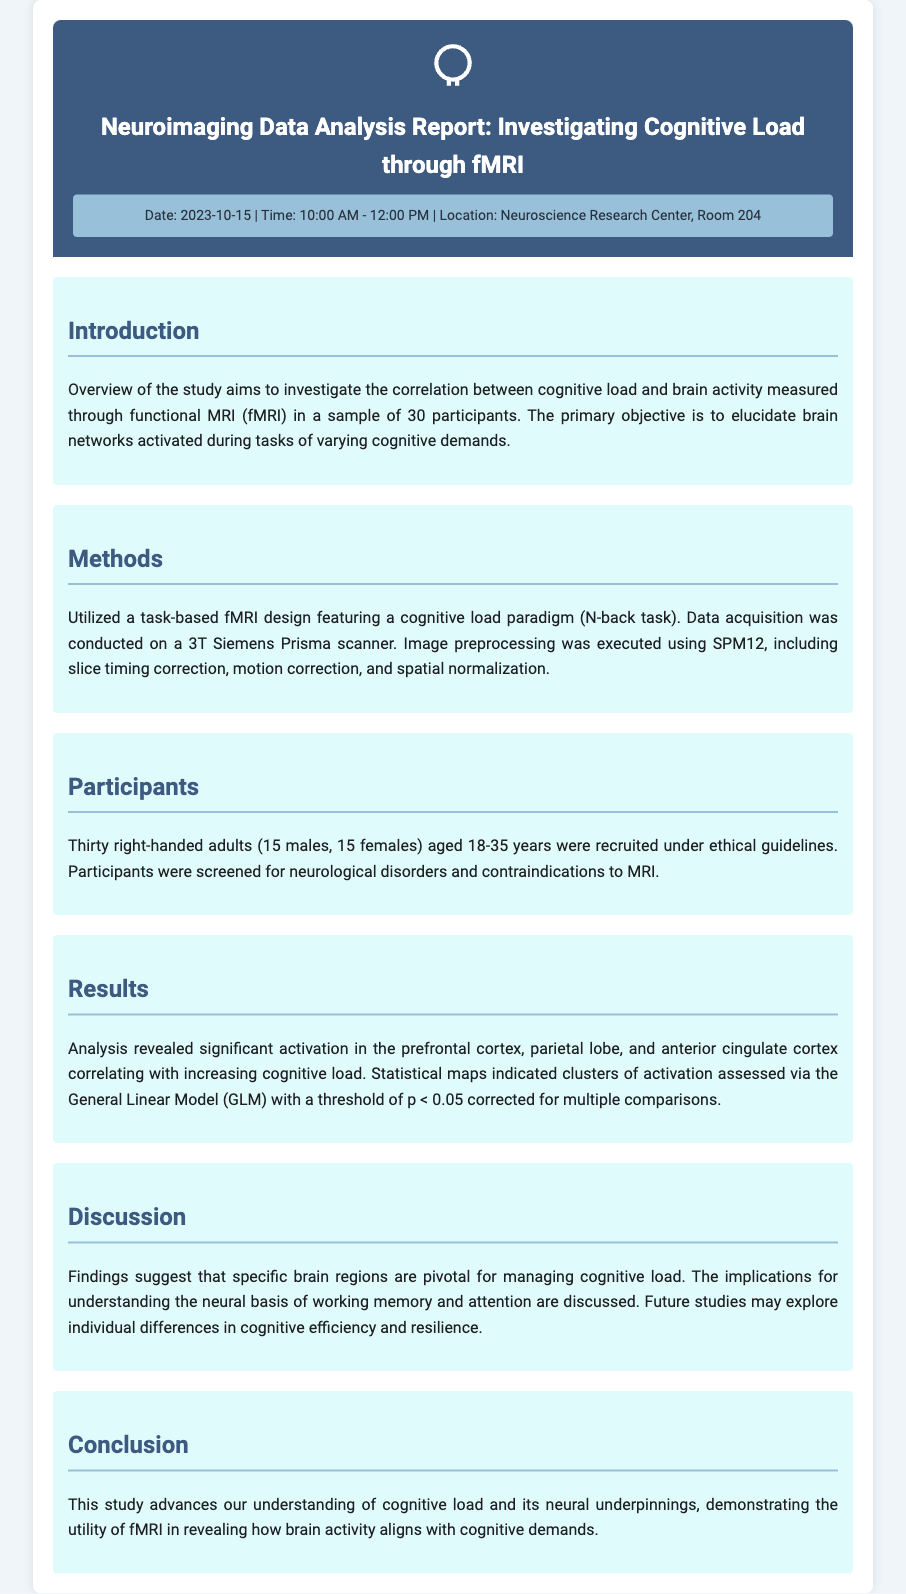What is the date of the report? The report is dated October 15, 2023.
Answer: October 15, 2023 How many participants were involved in the study? The study involved thirty participants.
Answer: Thirty What scanning method was used for data acquisition? The data acquisition was conducted using a 3T Siemens Prisma scanner.
Answer: 3T Siemens Prisma scanner Which brain regions showed significant activation? Significant activation was found in the prefrontal cortex, parietal lobe, and anterior cingulate cortex.
Answer: Prefrontal cortex, parietal lobe, anterior cingulate cortex What is the main cognitive task utilized in the study? The main cognitive task used was the N-back task.
Answer: N-back task What was the statistical threshold for significance? The threshold for significance was p < 0.05 corrected for multiple comparisons.
Answer: p < 0.05 Which gender was balanced in the participant selection? The participant selection included a balance of males and females.
Answer: Males and females What aspect of cognitive function is primarily being investigated? The study primarily investigates cognitive load.
Answer: Cognitive load 